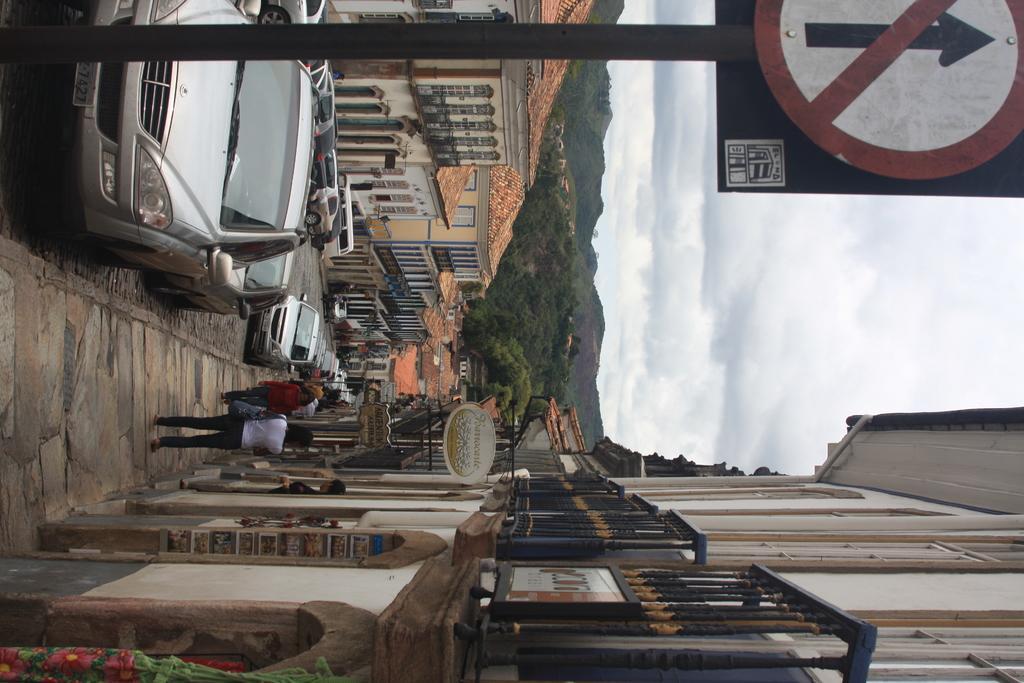Please provide a concise description of this image. As we can see in the image there are buildings, cars, few people here and there, sign pole, trees and sky. 